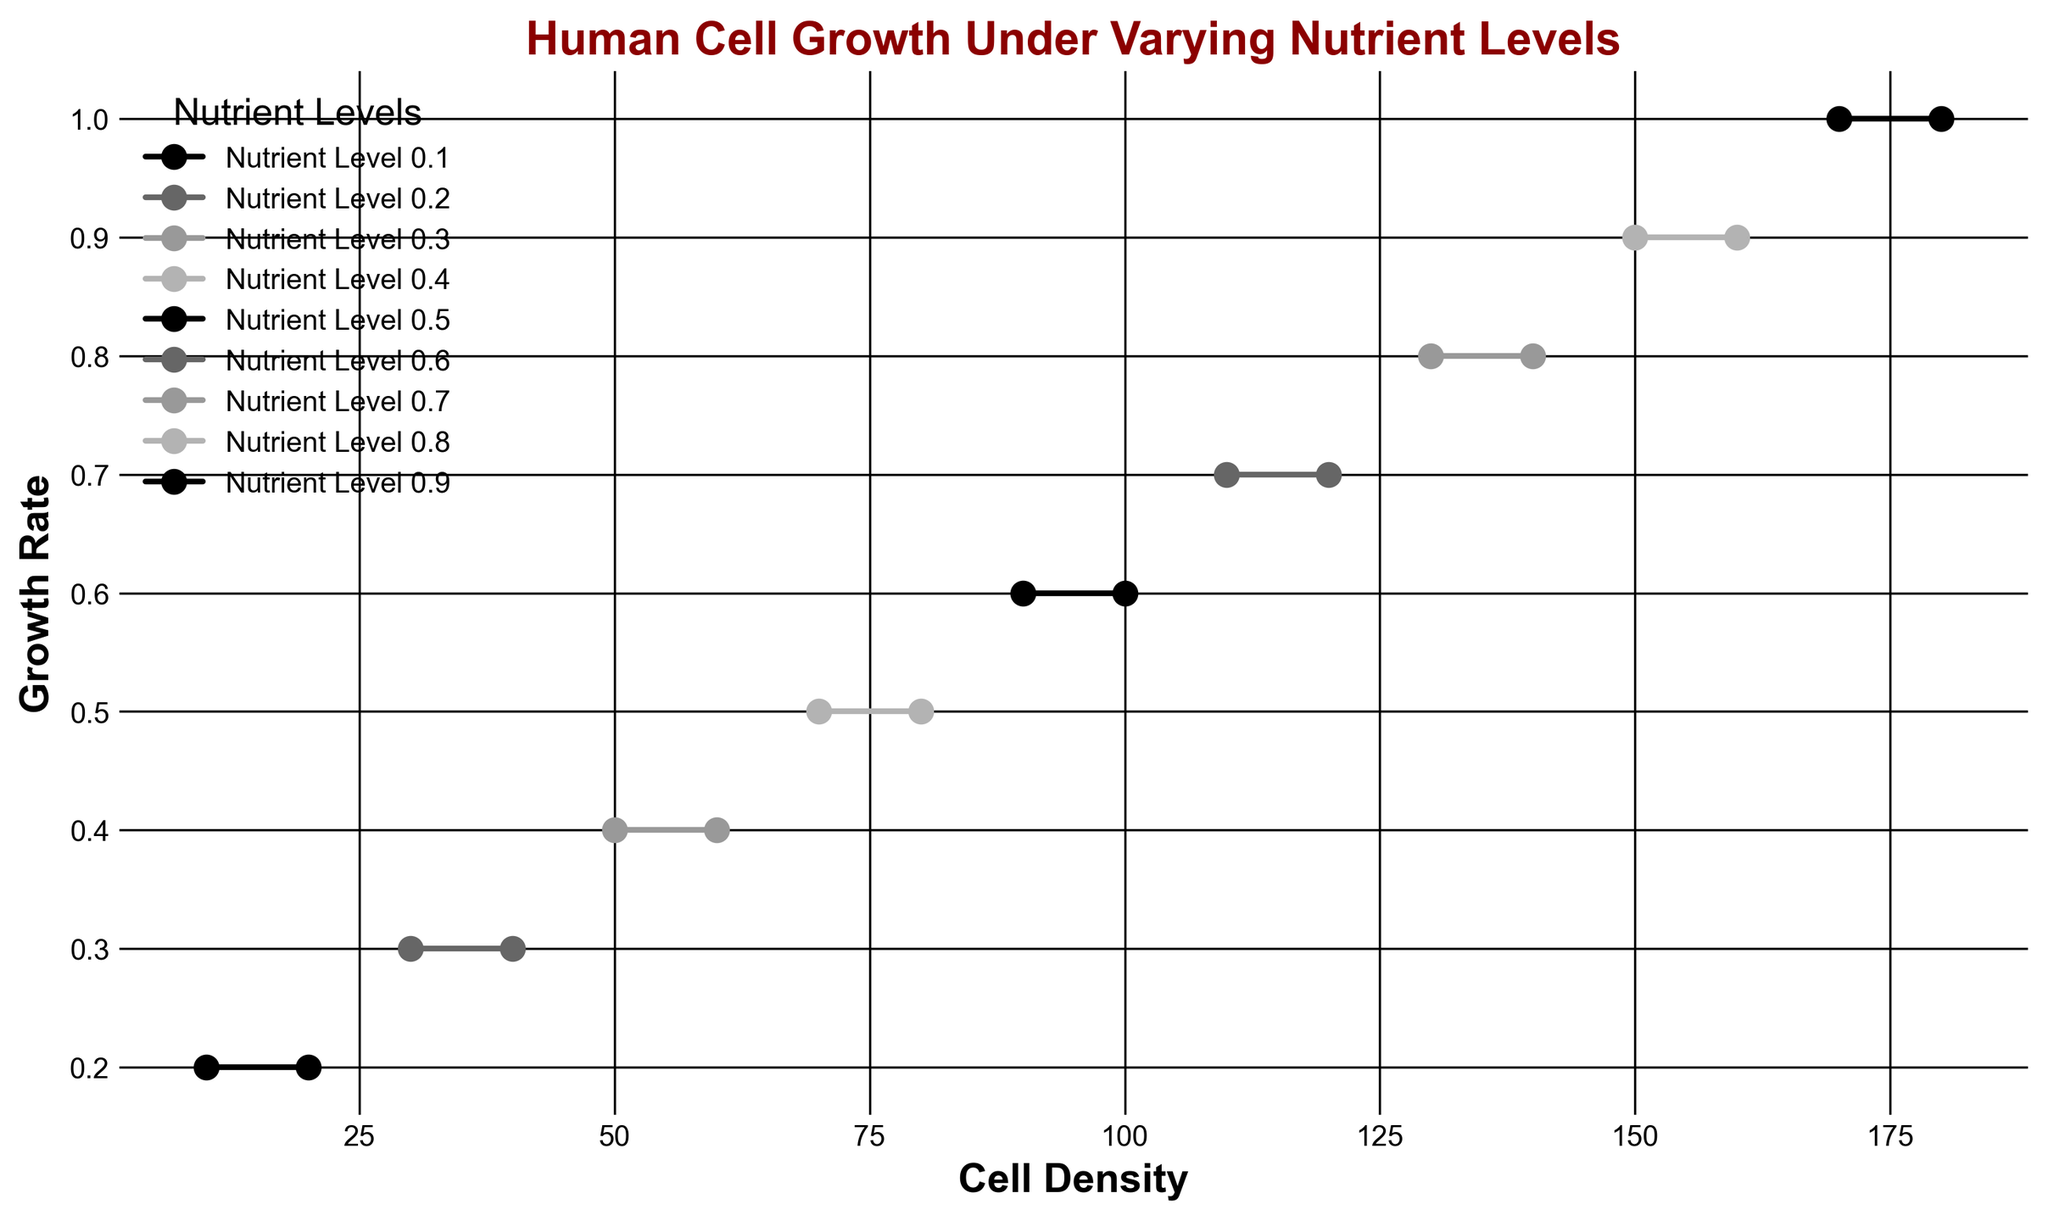What's the maximum cell density recorded in the figure? Observing the curve for each nutrient level, we find the cell density axis reaches up to 180.
Answer: 180 Which nutrient level corresponds to the steepest increase in growth rate as cell density increases? The steepest increase in growth rate means the line with the most significant slope. From the figure, the curve for 'Nutrient Level 0.9' shows the most rapid rise in growth rate as the cell density increases.
Answer: 0.9 At which nutrient level does the cell density of 100 correspond to a growth rate of 0.6? Locate the point where cell density is 100 on the x-axis and find the corresponding point on the curve that indicates a growth rate of 0.6. This point falls on the curve for 'Nutrient Level 0.5'.
Answer: 0.5 What's the increase in growth rate when nutrient level changes from 0.1 to 0.2, while cell density is held at 30? For 'Nutrient Level 0.1' at cell density of 30, the growth rate is 0.2. For 'Nutrient Level 0.2' at the same cell density, the growth rate is 0.3. The increase is 0.3 - 0.2 = 0.1.
Answer: 0.1 Which nutrient level has the highest final growth rate, and what is that rate? Observing the highest point for each curve, the 'Nutrient Level 0.9' reaches the maximum growth rate, which is 1.0.
Answer: 0.9, 1.0 For nutrient level 0.4, what is the average growth rate when cell density is 50 and 60? For 'Nutrient Level 0.4', at cell density 50, the growth rate is 0.4. At cell density 60, the growth rate is also 0.4. The average is (0.4 + 0.4) / 2 = 0.4.
Answer: 0.4 Is there a point where the growth rate is identical for two different nutrient levels at the same cell density? If so, provide an example. Yes, at cell density 80, both 'Nutrient Level 0.4' and 'Nutrient Level 0.5' show a growth rate of 0.5.
Answer: Yes, cell density 80, growth rate 0.5 for 0.4 and 0.5 nutrient levels At what cell density does the growth rate first reach 0.8 for the nutrient level 0.8? Trace the curve for 'Nutrient Level 0.8' until the growth rate marks 0.8, which occurs at a cell density of 130.
Answer: 130 What is the difference in growth rate between nutrient levels 0.3 and 0.5 at cell density 90? For 'Nutrient Level 0.3', the growth rate at cell density 90 is not shown directly, and for 'Nutrient Level 0.5' it's 0.6. Estimating from the general trend, the difference appears to be 0.6 - 0.35 (approximation) = 0.25.
Answer: 0.25 (approx) 